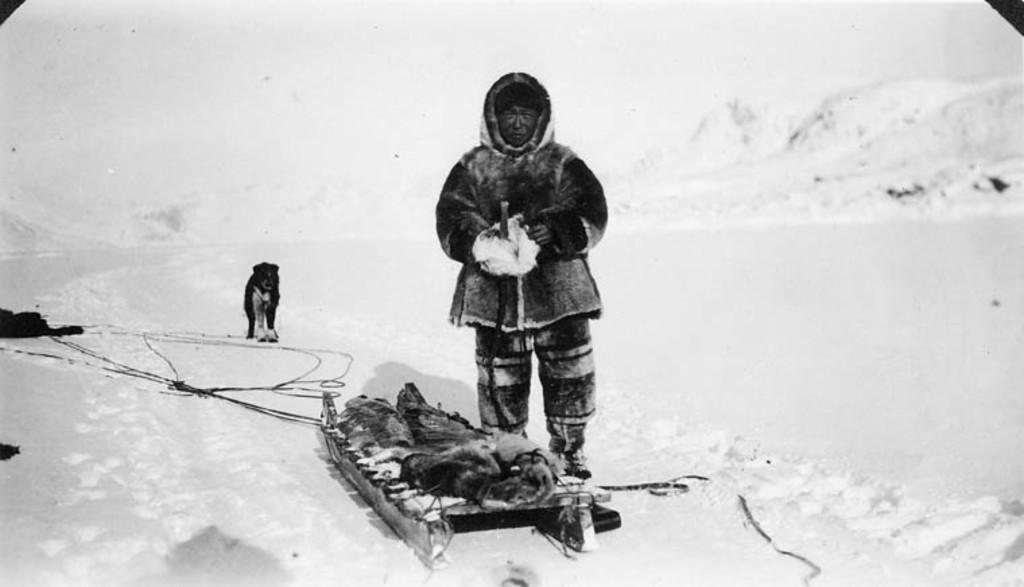Who or what can be seen in the image? There is a man and a dog in the image. What are the man and the dog doing in the image? Both the man and the dog are standing on the ground. Are there any other objects or elements in the image? Yes, there are objects on the ground. What is the color scheme of the image? The image is black and white in color. How many cakes are being served on the dock in the image? There are no cakes or docks present in the image. What is the size of the dog in the image? The size of the dog cannot be determined from the image alone, as there is no reference point for comparison. 